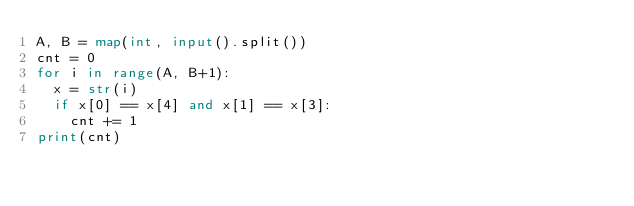<code> <loc_0><loc_0><loc_500><loc_500><_Python_>A, B = map(int, input().split())
cnt = 0
for i in range(A, B+1):
  x = str(i)
  if x[0] == x[4] and x[1] == x[3]:
    cnt += 1
print(cnt)</code> 